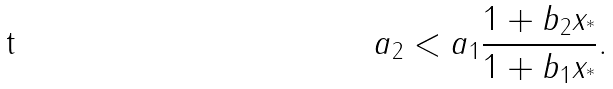<formula> <loc_0><loc_0><loc_500><loc_500>a _ { 2 } < a _ { 1 } \frac { 1 + b _ { 2 } x _ { ^ { * } } } { 1 + b _ { 1 } x _ { ^ { * } } } .</formula> 